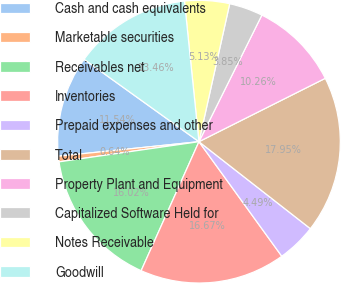Convert chart to OTSL. <chart><loc_0><loc_0><loc_500><loc_500><pie_chart><fcel>Cash and cash equivalents<fcel>Marketable securities<fcel>Receivables net<fcel>Inventories<fcel>Prepaid expenses and other<fcel>Total<fcel>Property Plant and Equipment<fcel>Capitalized Software Held for<fcel>Notes Receivable<fcel>Goodwill<nl><fcel>11.54%<fcel>0.64%<fcel>16.02%<fcel>16.67%<fcel>4.49%<fcel>17.95%<fcel>10.26%<fcel>3.85%<fcel>5.13%<fcel>13.46%<nl></chart> 